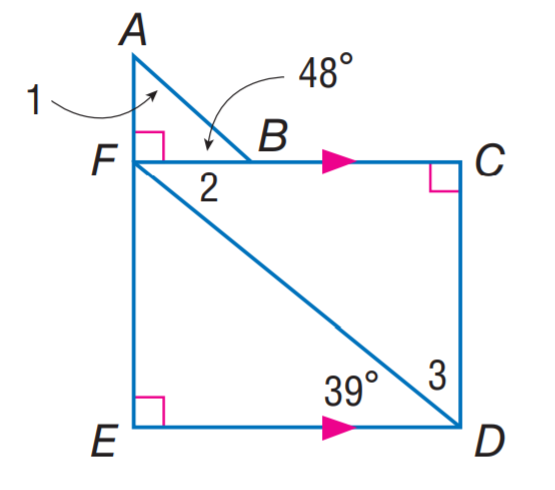Question: Find m \angle 3.
Choices:
A. 39
B. 42
C. 48
D. 51
Answer with the letter. Answer: D Question: Find m \angle 3.
Choices:
A. 39
B. 42
C. 48
D. 51
Answer with the letter. Answer: D 